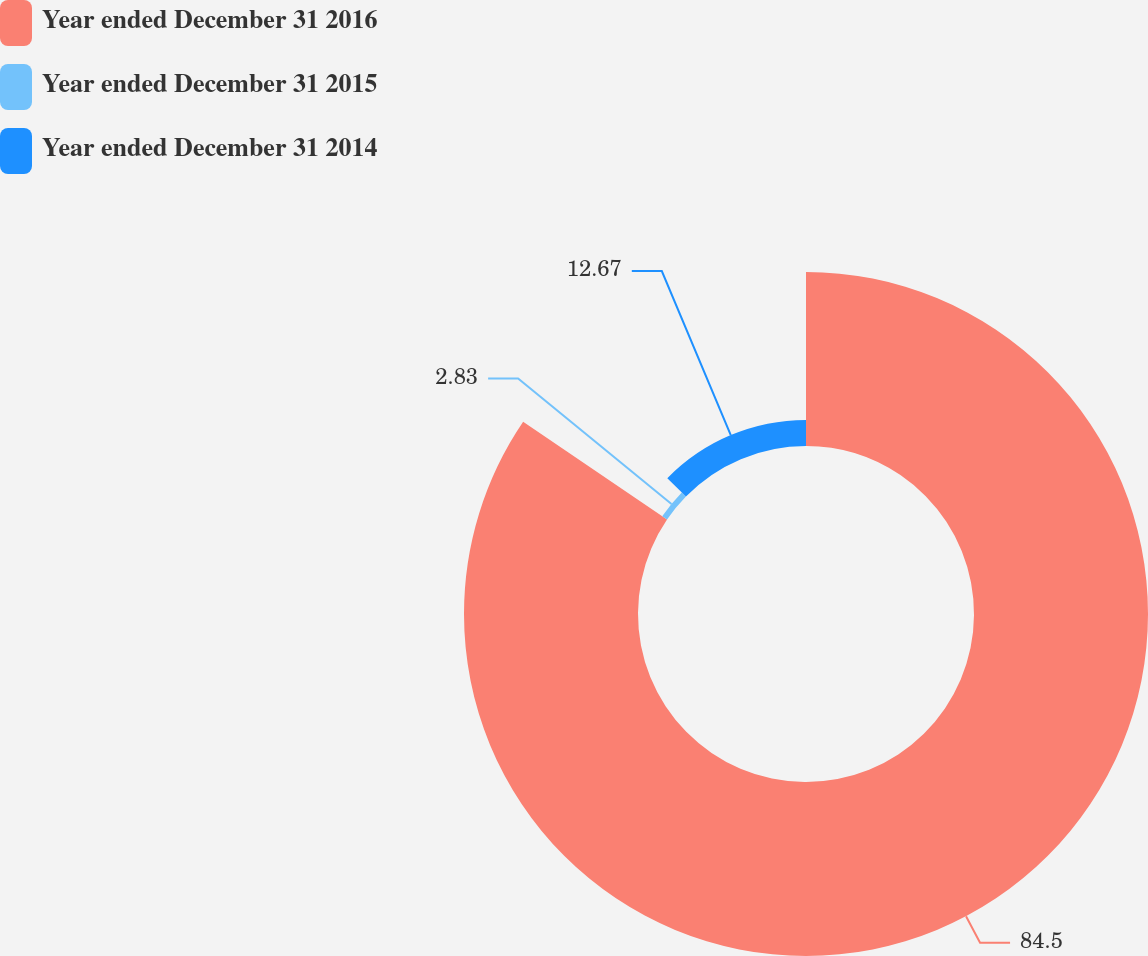Convert chart. <chart><loc_0><loc_0><loc_500><loc_500><pie_chart><fcel>Year ended December 31 2016<fcel>Year ended December 31 2015<fcel>Year ended December 31 2014<nl><fcel>84.5%<fcel>2.83%<fcel>12.67%<nl></chart> 